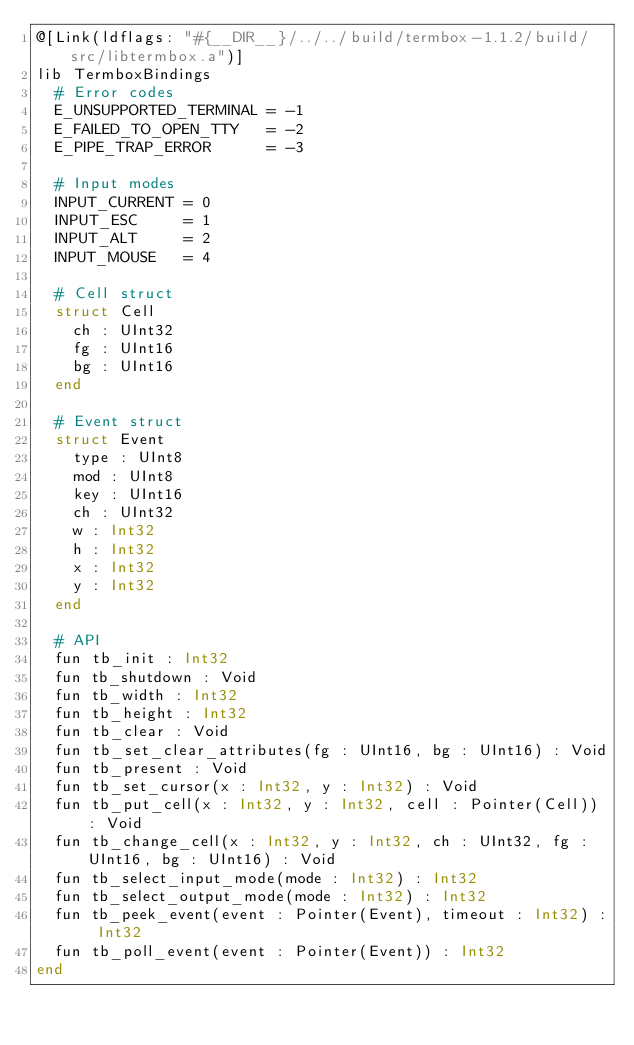Convert code to text. <code><loc_0><loc_0><loc_500><loc_500><_Crystal_>@[Link(ldflags: "#{__DIR__}/../../build/termbox-1.1.2/build/src/libtermbox.a")]
lib TermboxBindings
  # Error codes
  E_UNSUPPORTED_TERMINAL = -1
  E_FAILED_TO_OPEN_TTY   = -2
  E_PIPE_TRAP_ERROR      = -3

  # Input modes
  INPUT_CURRENT = 0
  INPUT_ESC     = 1
  INPUT_ALT     = 2
  INPUT_MOUSE   = 4

  # Cell struct
  struct Cell
    ch : UInt32
    fg : UInt16
    bg : UInt16
  end

  # Event struct
  struct Event
    type : UInt8
    mod : UInt8
    key : UInt16
    ch : UInt32
    w : Int32
    h : Int32
    x : Int32
    y : Int32
  end

  # API
  fun tb_init : Int32
  fun tb_shutdown : Void
  fun tb_width : Int32
  fun tb_height : Int32
  fun tb_clear : Void
  fun tb_set_clear_attributes(fg : UInt16, bg : UInt16) : Void
  fun tb_present : Void
  fun tb_set_cursor(x : Int32, y : Int32) : Void
  fun tb_put_cell(x : Int32, y : Int32, cell : Pointer(Cell)) : Void
  fun tb_change_cell(x : Int32, y : Int32, ch : UInt32, fg : UInt16, bg : UInt16) : Void
  fun tb_select_input_mode(mode : Int32) : Int32
  fun tb_select_output_mode(mode : Int32) : Int32
  fun tb_peek_event(event : Pointer(Event), timeout : Int32) : Int32
  fun tb_poll_event(event : Pointer(Event)) : Int32
end
</code> 